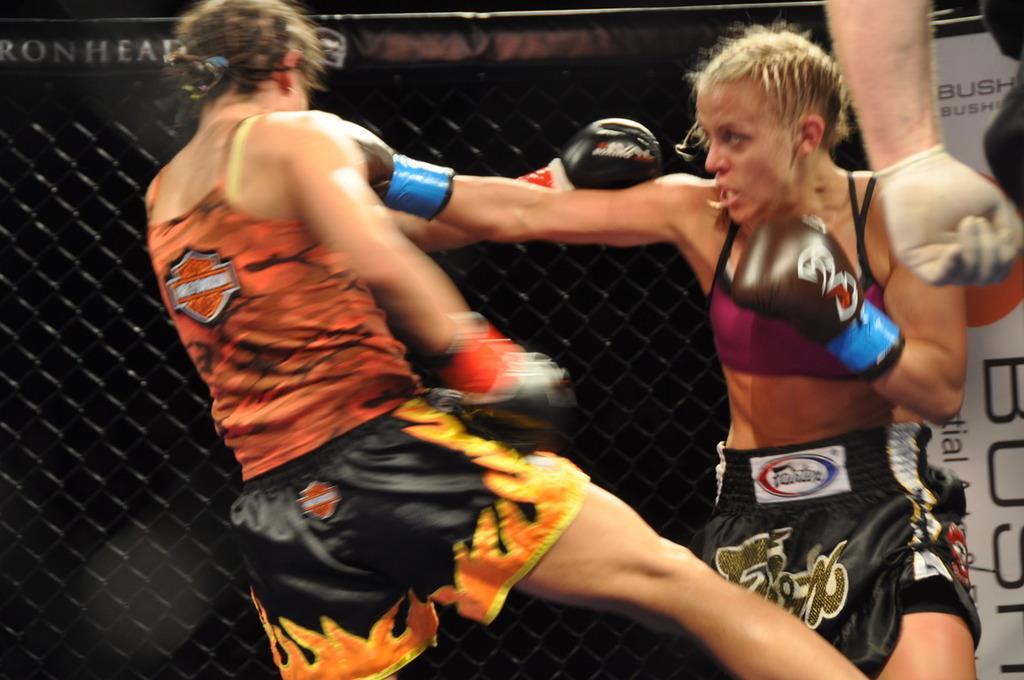How would you summarize this image in a sentence or two? In this picture there are two women boxing and we can see mesh and banner. In the background of the image it is dark. In the top right side of the image we can see a hand of a person with glove. 